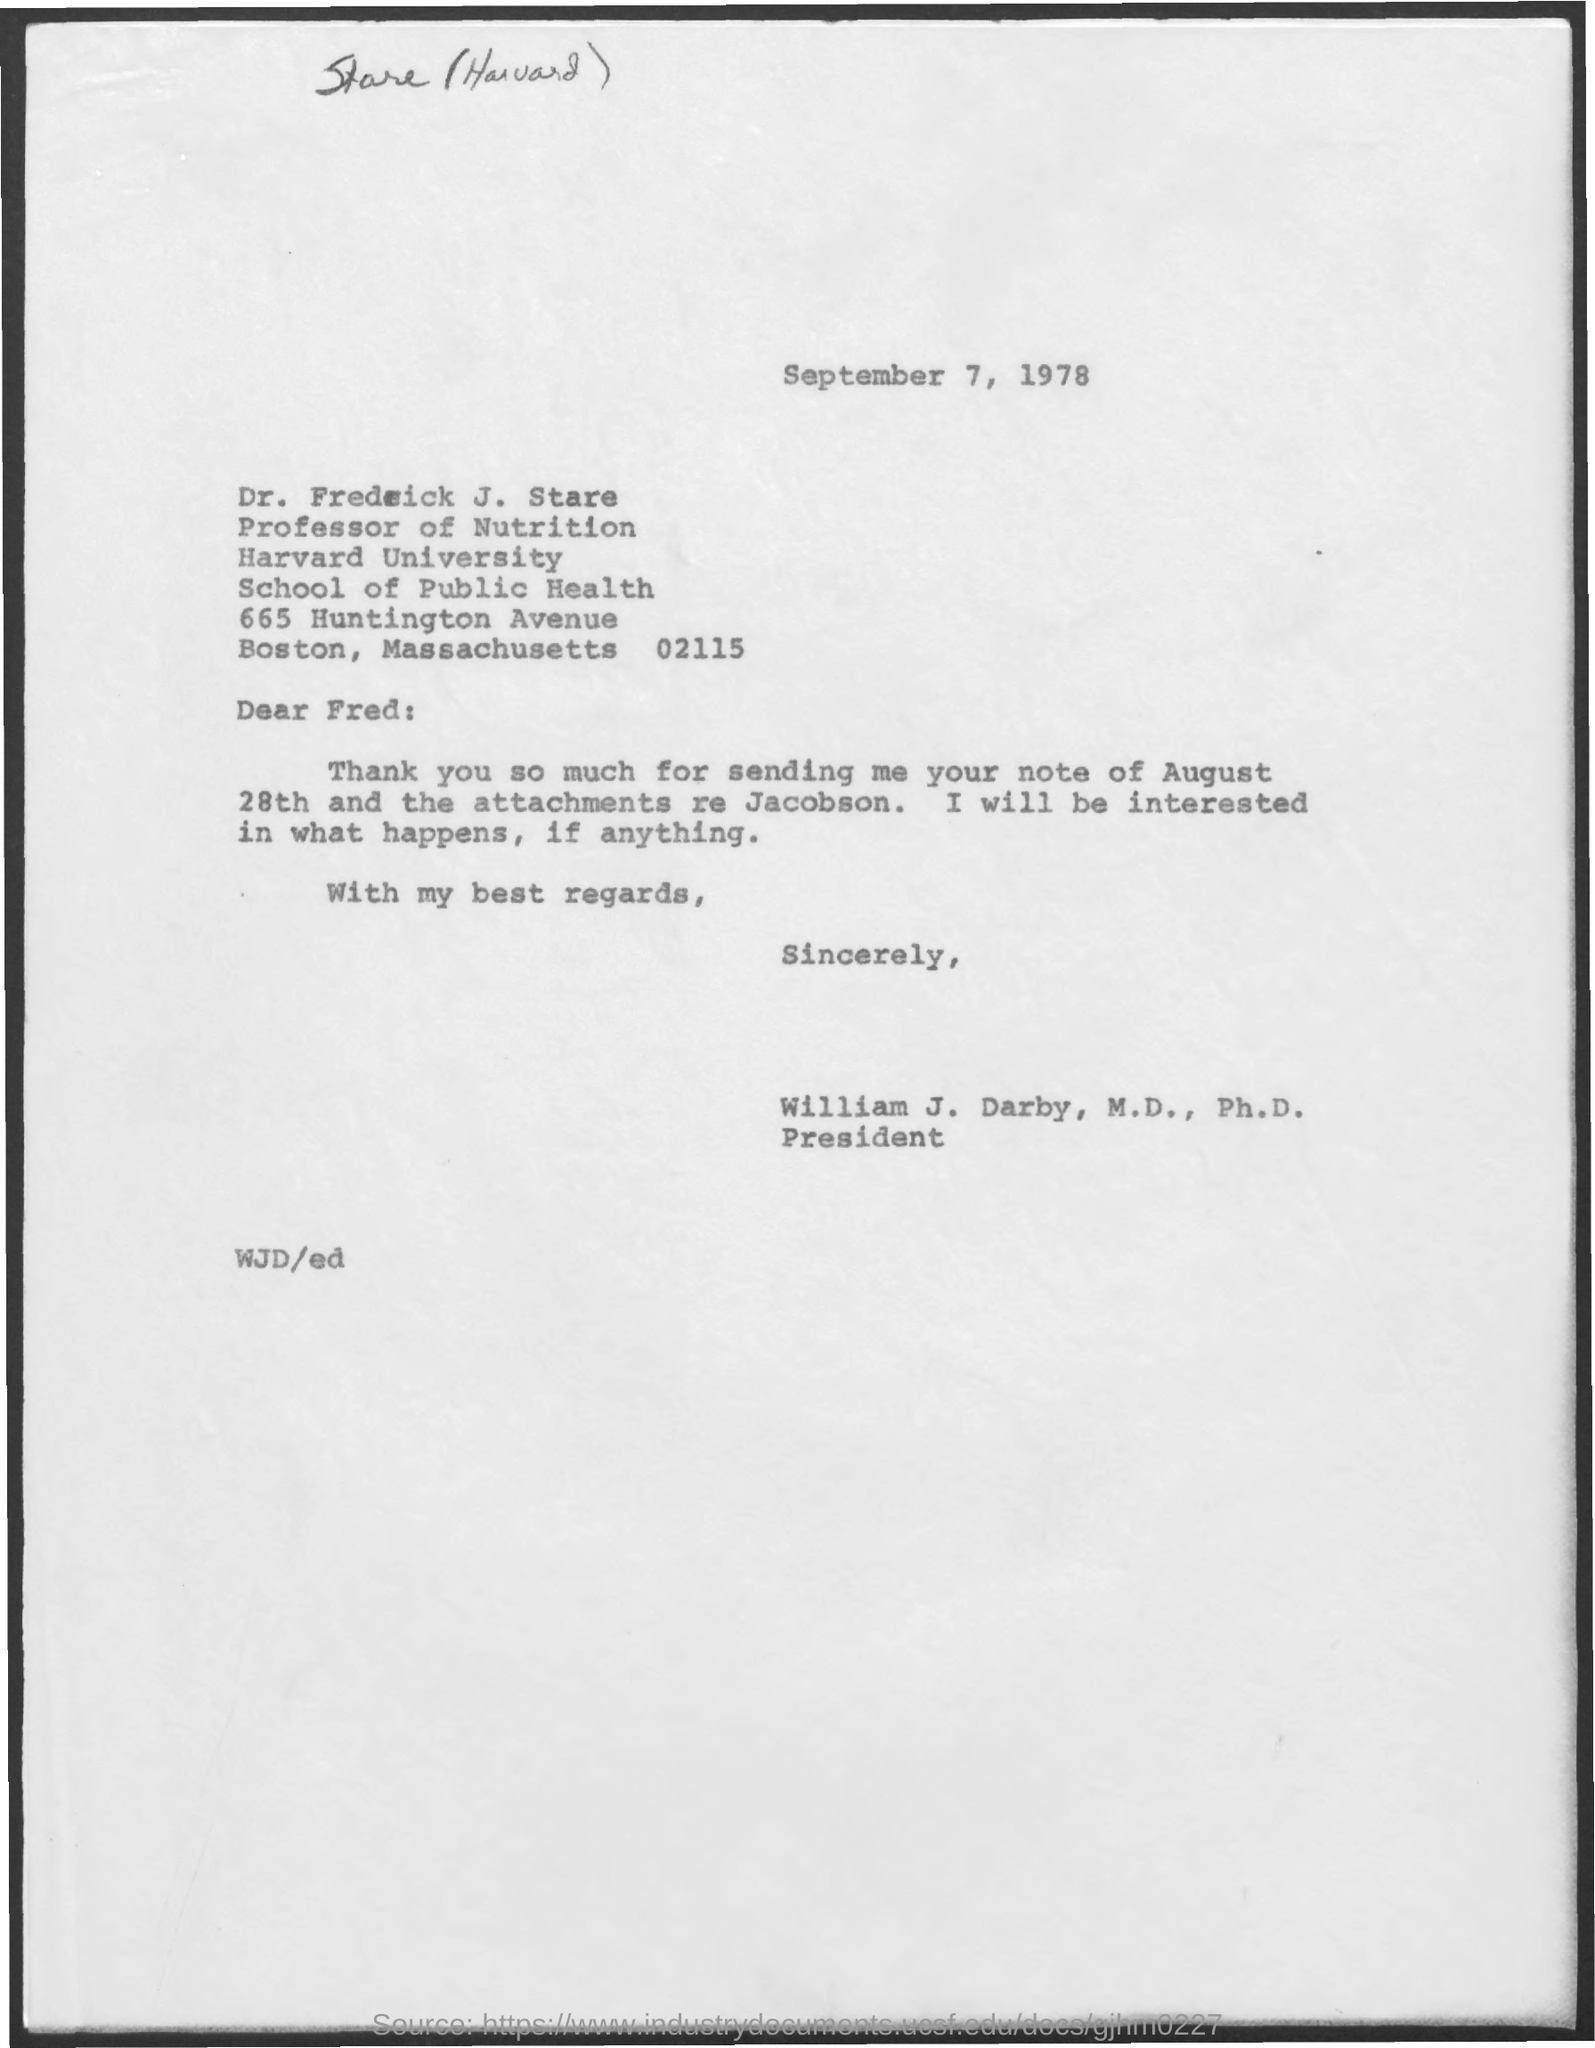Indicate a few pertinent items in this graphic. The letter was sent to Fred. Dr. Frederick J. Stare holds the title of Professor of Nutrition. The name of the university mentioned in the given form is Harvard University. The date mentioned in the given page is September 7, 1978. William J. Darby is listed as a president in the designation. 